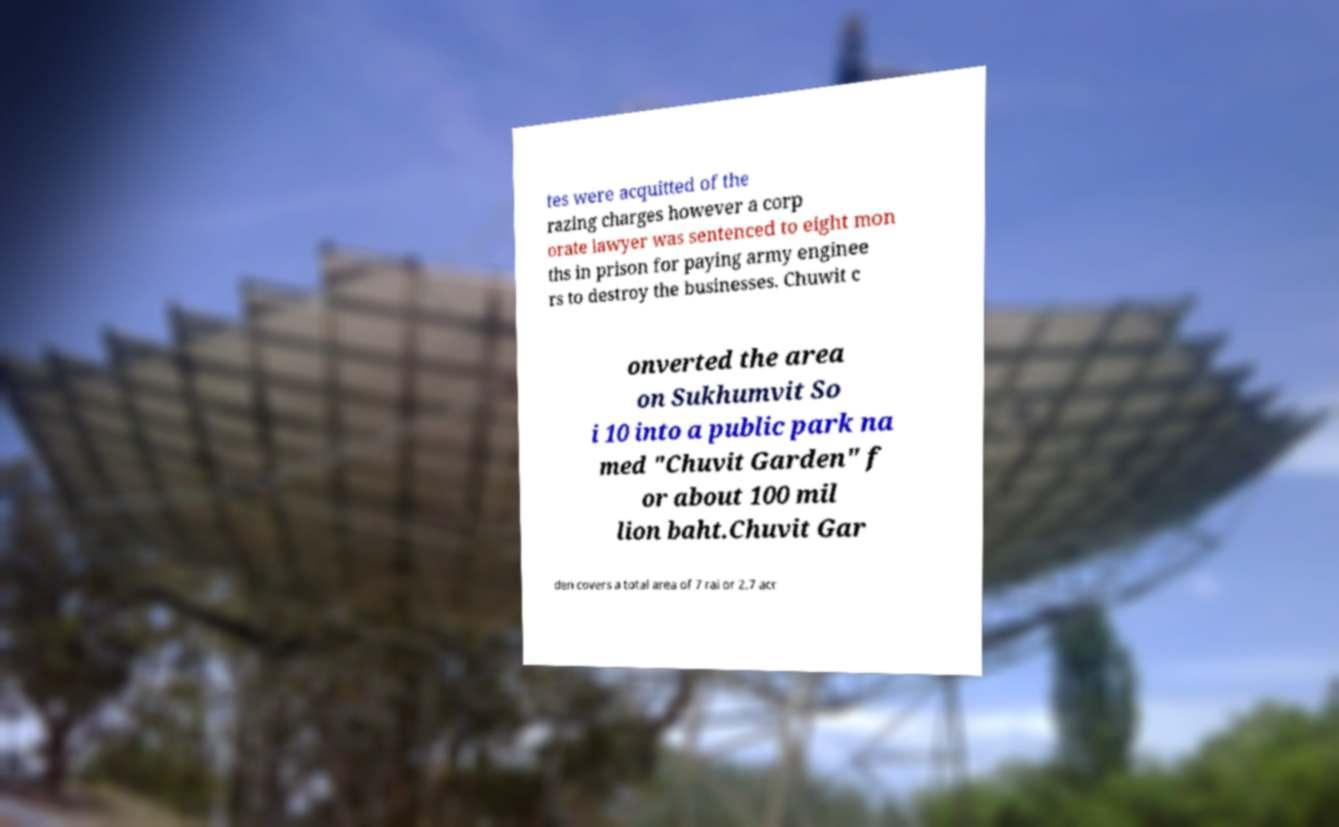Can you accurately transcribe the text from the provided image for me? tes were acquitted of the razing charges however a corp orate lawyer was sentenced to eight mon ths in prison for paying army enginee rs to destroy the businesses. Chuwit c onverted the area on Sukhumvit So i 10 into a public park na med "Chuvit Garden" f or about 100 mil lion baht.Chuvit Gar den covers a total area of 7 rai or 2.7 acr 